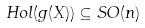<formula> <loc_0><loc_0><loc_500><loc_500>H o l ( g ( X ) ) \subseteq S O ( n )</formula> 